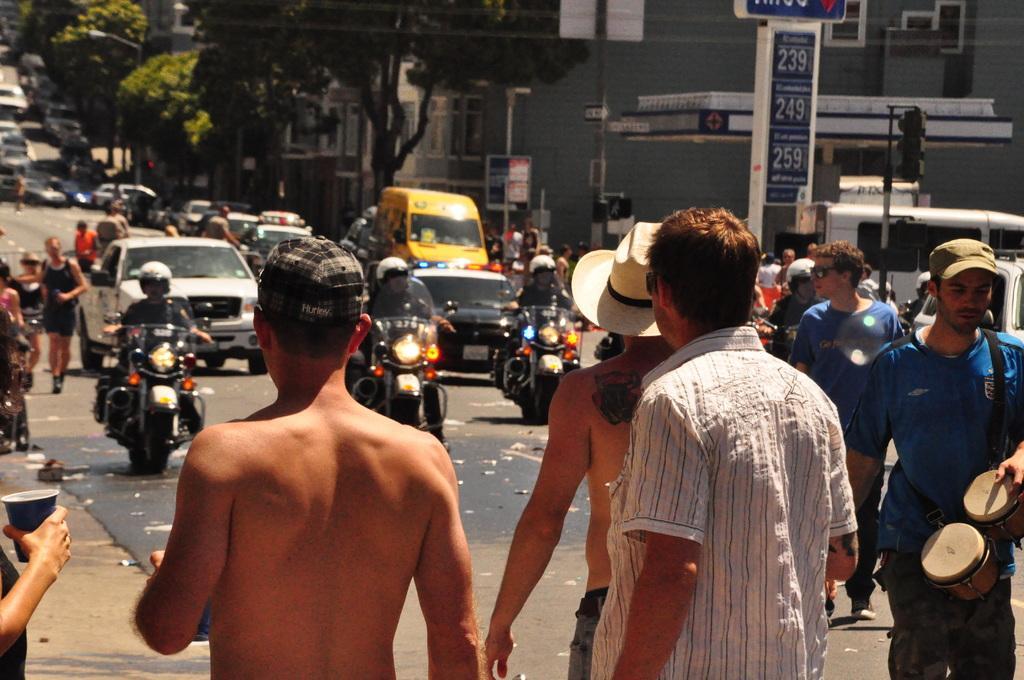How would you summarize this image in a sentence or two? in This picture we see few people moving on vehicles and we see few people are standing on the road and we see some buildings and couple of trees 